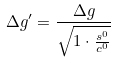Convert formula to latex. <formula><loc_0><loc_0><loc_500><loc_500>\Delta g ^ { \prime } = \frac { \Delta g } { \sqrt { 1 \cdot \frac { s ^ { 0 } } { c ^ { 0 } } } }</formula> 